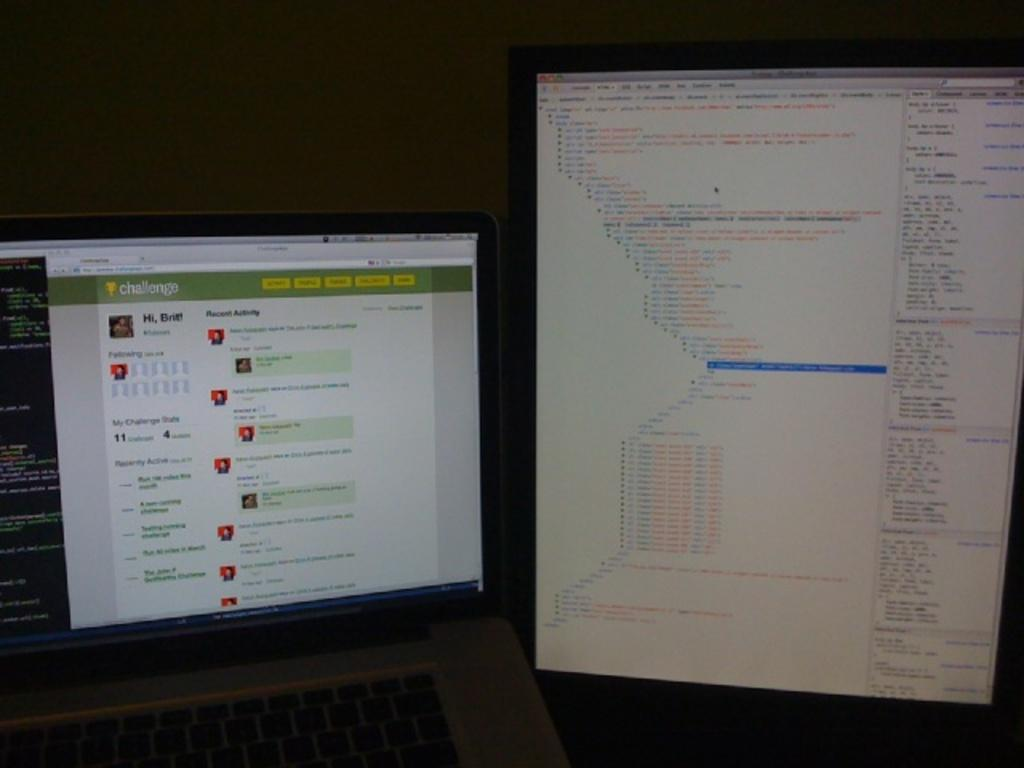Provide a one-sentence caption for the provided image. two screens with one of them on a tab that says recent activity on it. 